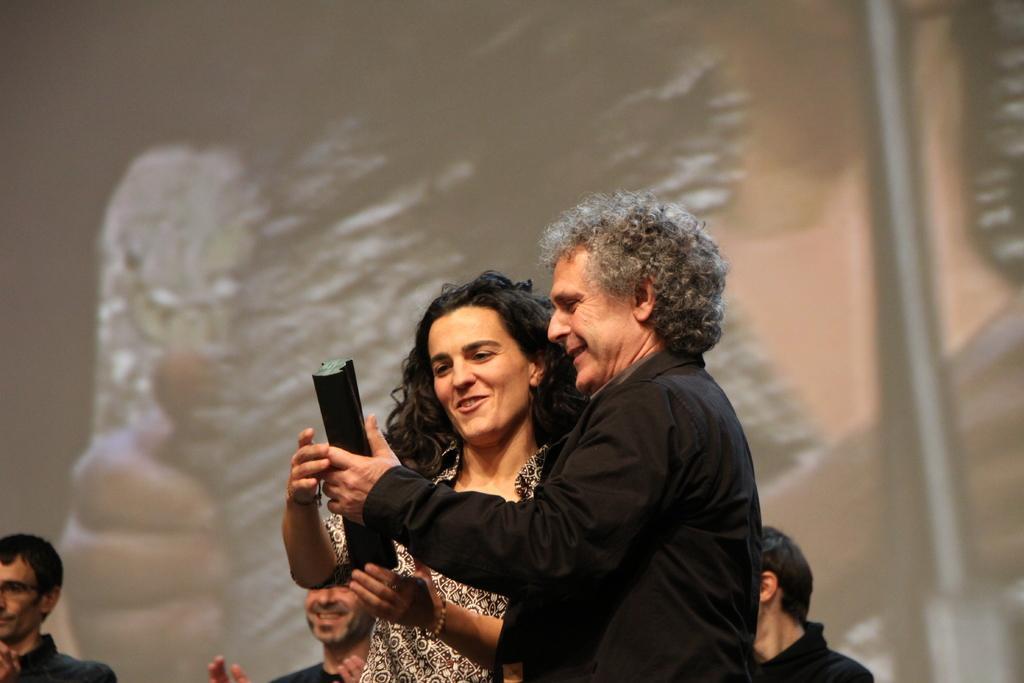Could you give a brief overview of what you see in this image? In this picture we can see few people, in the middle of the image we can see a man, he is holding an object, behind them we can see a screen. 